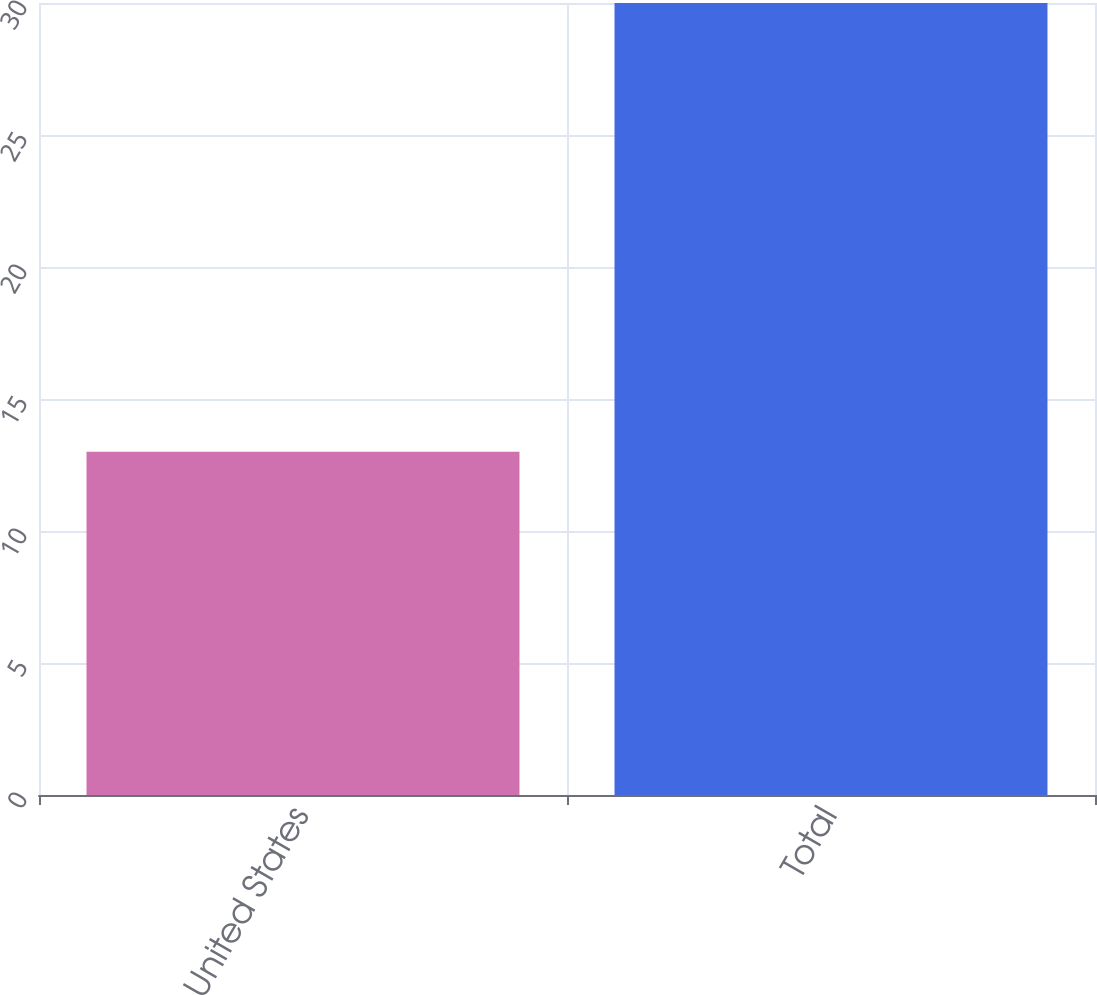Convert chart to OTSL. <chart><loc_0><loc_0><loc_500><loc_500><bar_chart><fcel>United States<fcel>Total<nl><fcel>13<fcel>30<nl></chart> 